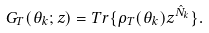Convert formula to latex. <formula><loc_0><loc_0><loc_500><loc_500>G _ { T } ( \theta _ { k } ; z ) = T r \{ \rho _ { T } ( \theta _ { k } ) z ^ { \hat { N } _ { k } } \} .</formula> 